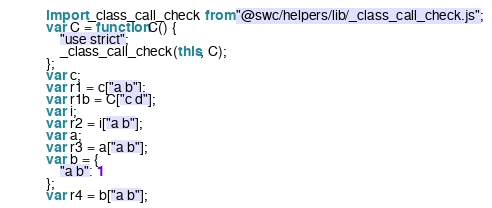<code> <loc_0><loc_0><loc_500><loc_500><_JavaScript_>import _class_call_check from "@swc/helpers/lib/_class_call_check.js";
var C = function C() {
    "use strict";
    _class_call_check(this, C);
};
var c;
var r1 = c["a b"];
var r1b = C["c d"];
var i;
var r2 = i["a b"];
var a;
var r3 = a["a b"];
var b = {
    "a b": 1
};
var r4 = b["a b"];
</code> 